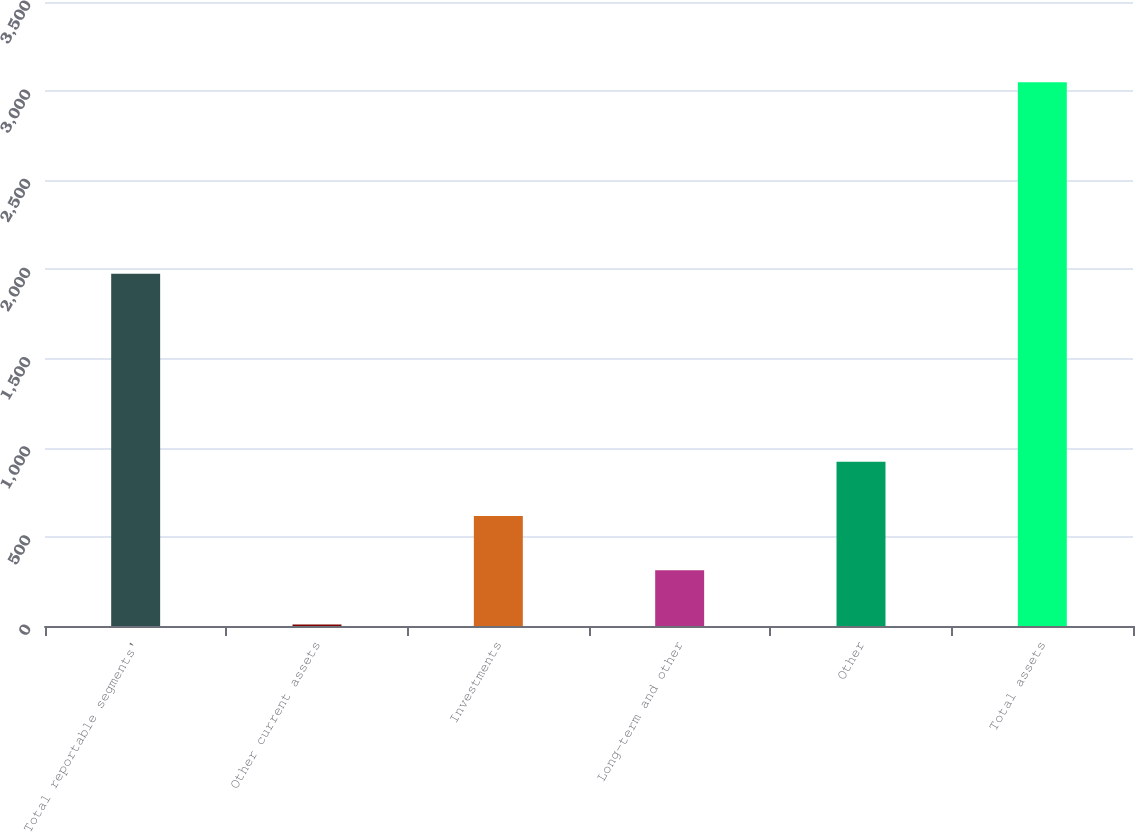Convert chart to OTSL. <chart><loc_0><loc_0><loc_500><loc_500><bar_chart><fcel>Total reportable segments'<fcel>Other current assets<fcel>Investments<fcel>Long-term and other<fcel>Other<fcel>Total assets<nl><fcel>1976<fcel>9<fcel>617.2<fcel>313.1<fcel>921.3<fcel>3050<nl></chart> 